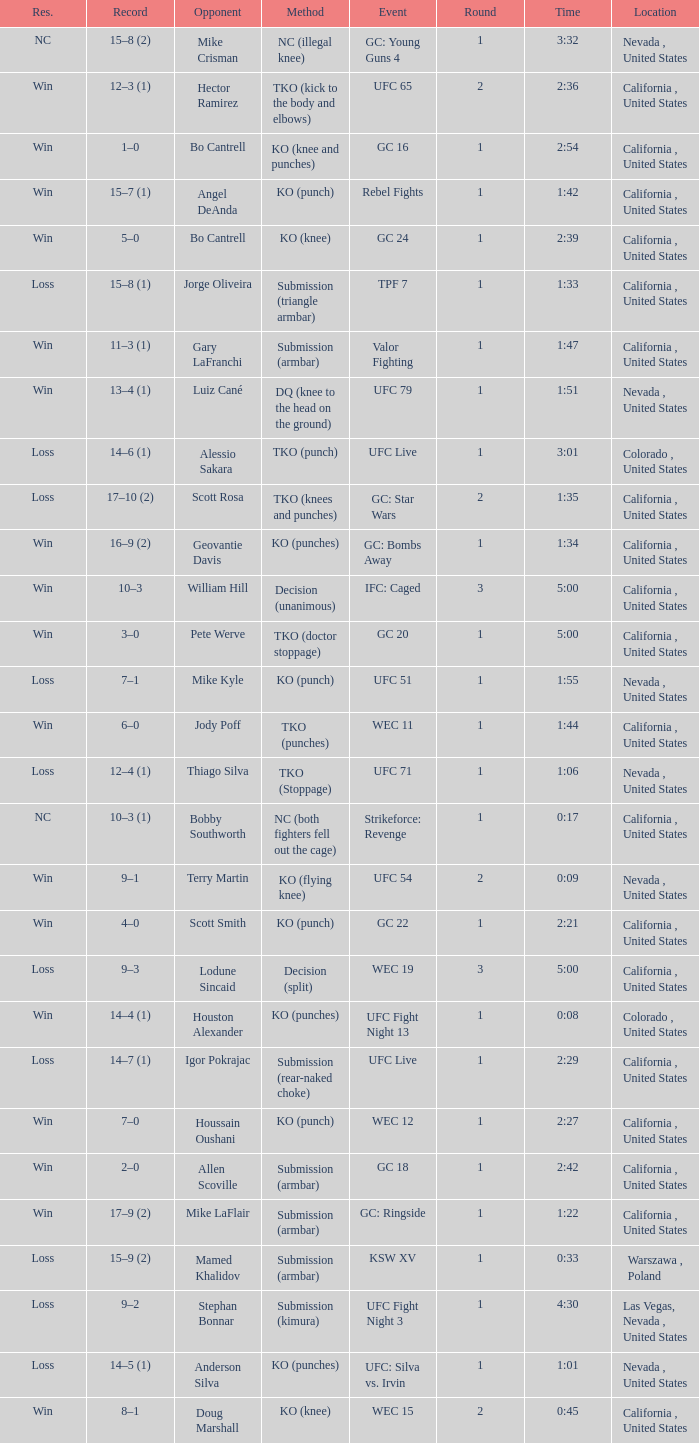What was the method when the time was 1:01? KO (punches). 